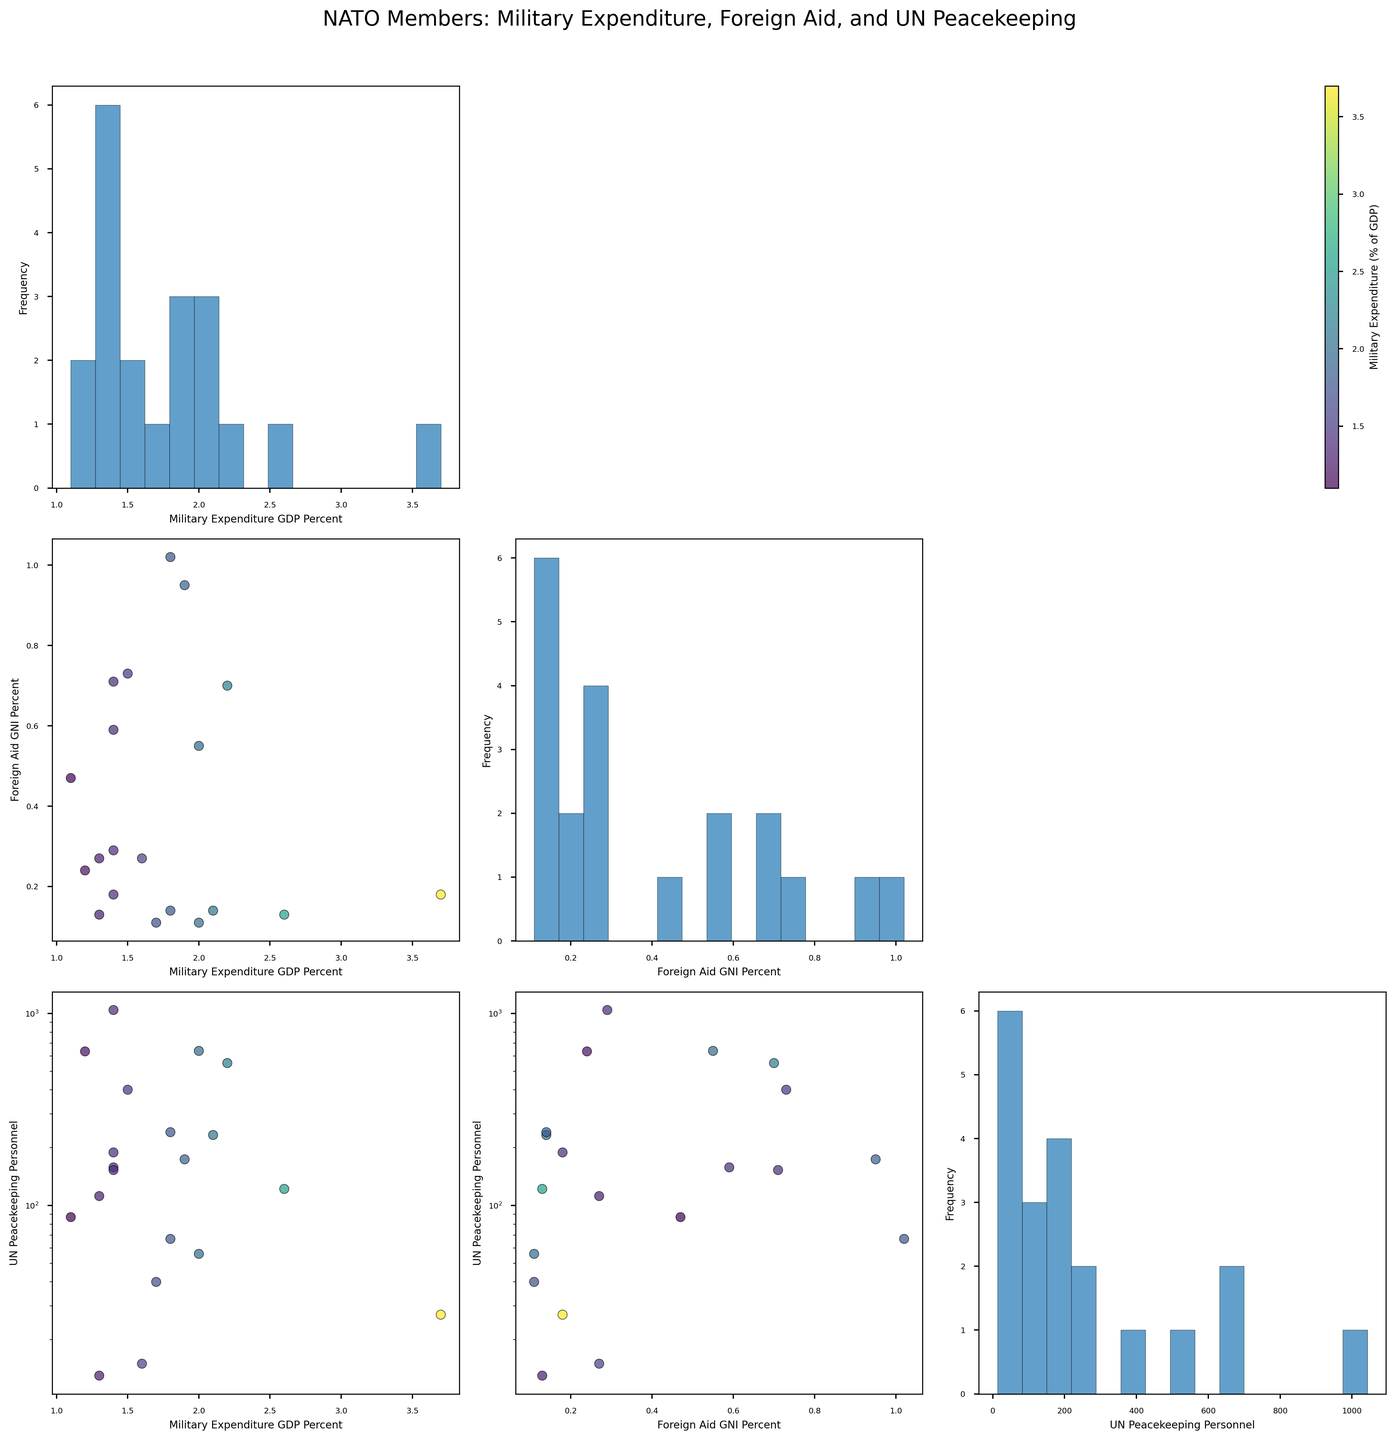What is the title of the scatterplot matrix? The title is displayed at the top center of the figure, it summarizes the overall theme of the plot.
Answer: NATO Members: Military Expenditure, Foreign Aid, and UN Peacekeeping Which country has the highest percentage of GDP spent on military expenditure? Locate the scatter points where the x-axis or y-axis represents 'Military Expenditure (% of GDP).' Find the highest value on this axis and identify the corresponding country.
Answer: United States In the scatterplot comparing 'Foreign Aid (% of GNI)' and 'Military Expenditure (% of GDP),' which country is an outlier in terms of 'Foreign Aid'? Locate the scatterplot where the x-axis is 'Foreign Aid (% of GNI)' and the y-axis is 'Military Expenditure (% of GDP).' Identify any point far from the cluster, which would be the outlier.
Answer: Norway Is there a positive or negative correlation between 'Military Expenditure (% of GDP)' and 'Foreign Aid (% of GNI)'? Check the general trend of the scatter points in the scatterplot where these two axes intersect. If points tend to go up-right, it’s positive; if down-right, it’s negative.
Answer: Negative Which two countries have similar 'Military Expenditure (% of GDP)' but different 'Foreign Aid (% of GNI)'? Find a pair of countries that are close on the 'Military Expenditure (% of GDP)' axis but have distinct values on the 'Foreign Aid (% of GNI)' axis.
Answer: France and Germany What is the approximate range of 'UN Peacekeeping Personnel' among NATO countries? Look at the scatterplots involving 'UN Peacekeeping Personnel' on either axis (log scale) and identify the minimum and maximum values.
Answer: Approximately 10 to 1043 Which country contributes the most personnel to UN peacekeeping missions? Locate the scatterplot where 'UN Peacekeeping Personnel' is on one of the axes. Identify the highest point on that axis and determine the corresponding country.
Answer: Italy How does 'UN Peacekeeping Personnel' participation vary with respect to 'Military Expenditure (% of GDP)'? Examine the scatterplot where 'Military Expenditure (% of GDP)' is on the x-axis and 'UN Peacekeeping Personnel' on the y-axis. Describe any noticeable patterns or trends.
Answer: There doesn't appear to be a strong correlation; variations are arbitrary Which axis representation uses a logarithmic scale in the scatterplots? Identify the common axis among scatterplots that uses a logarithmic scale by inspecting the tick marks and labels, which often change exponentially.
Answer: 'UN Peacekeeping Personnel' 